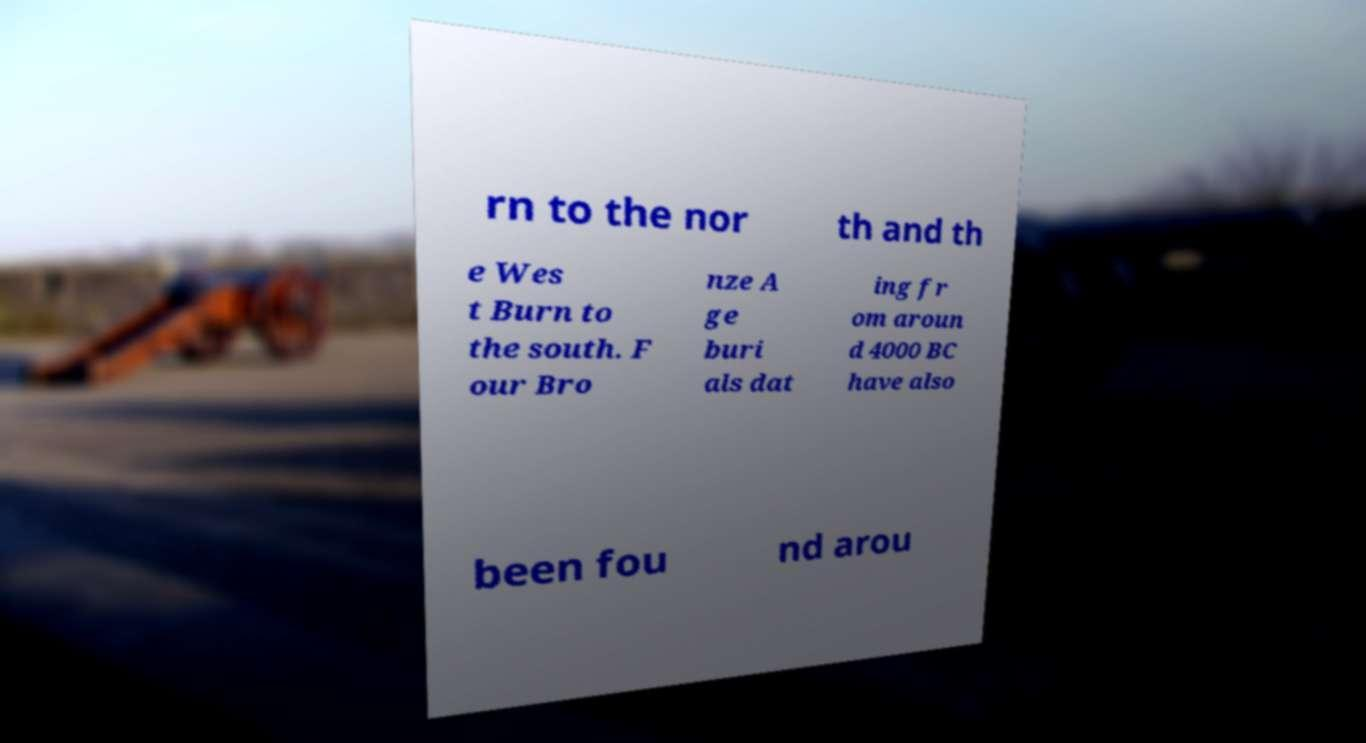What messages or text are displayed in this image? I need them in a readable, typed format. rn to the nor th and th e Wes t Burn to the south. F our Bro nze A ge buri als dat ing fr om aroun d 4000 BC have also been fou nd arou 